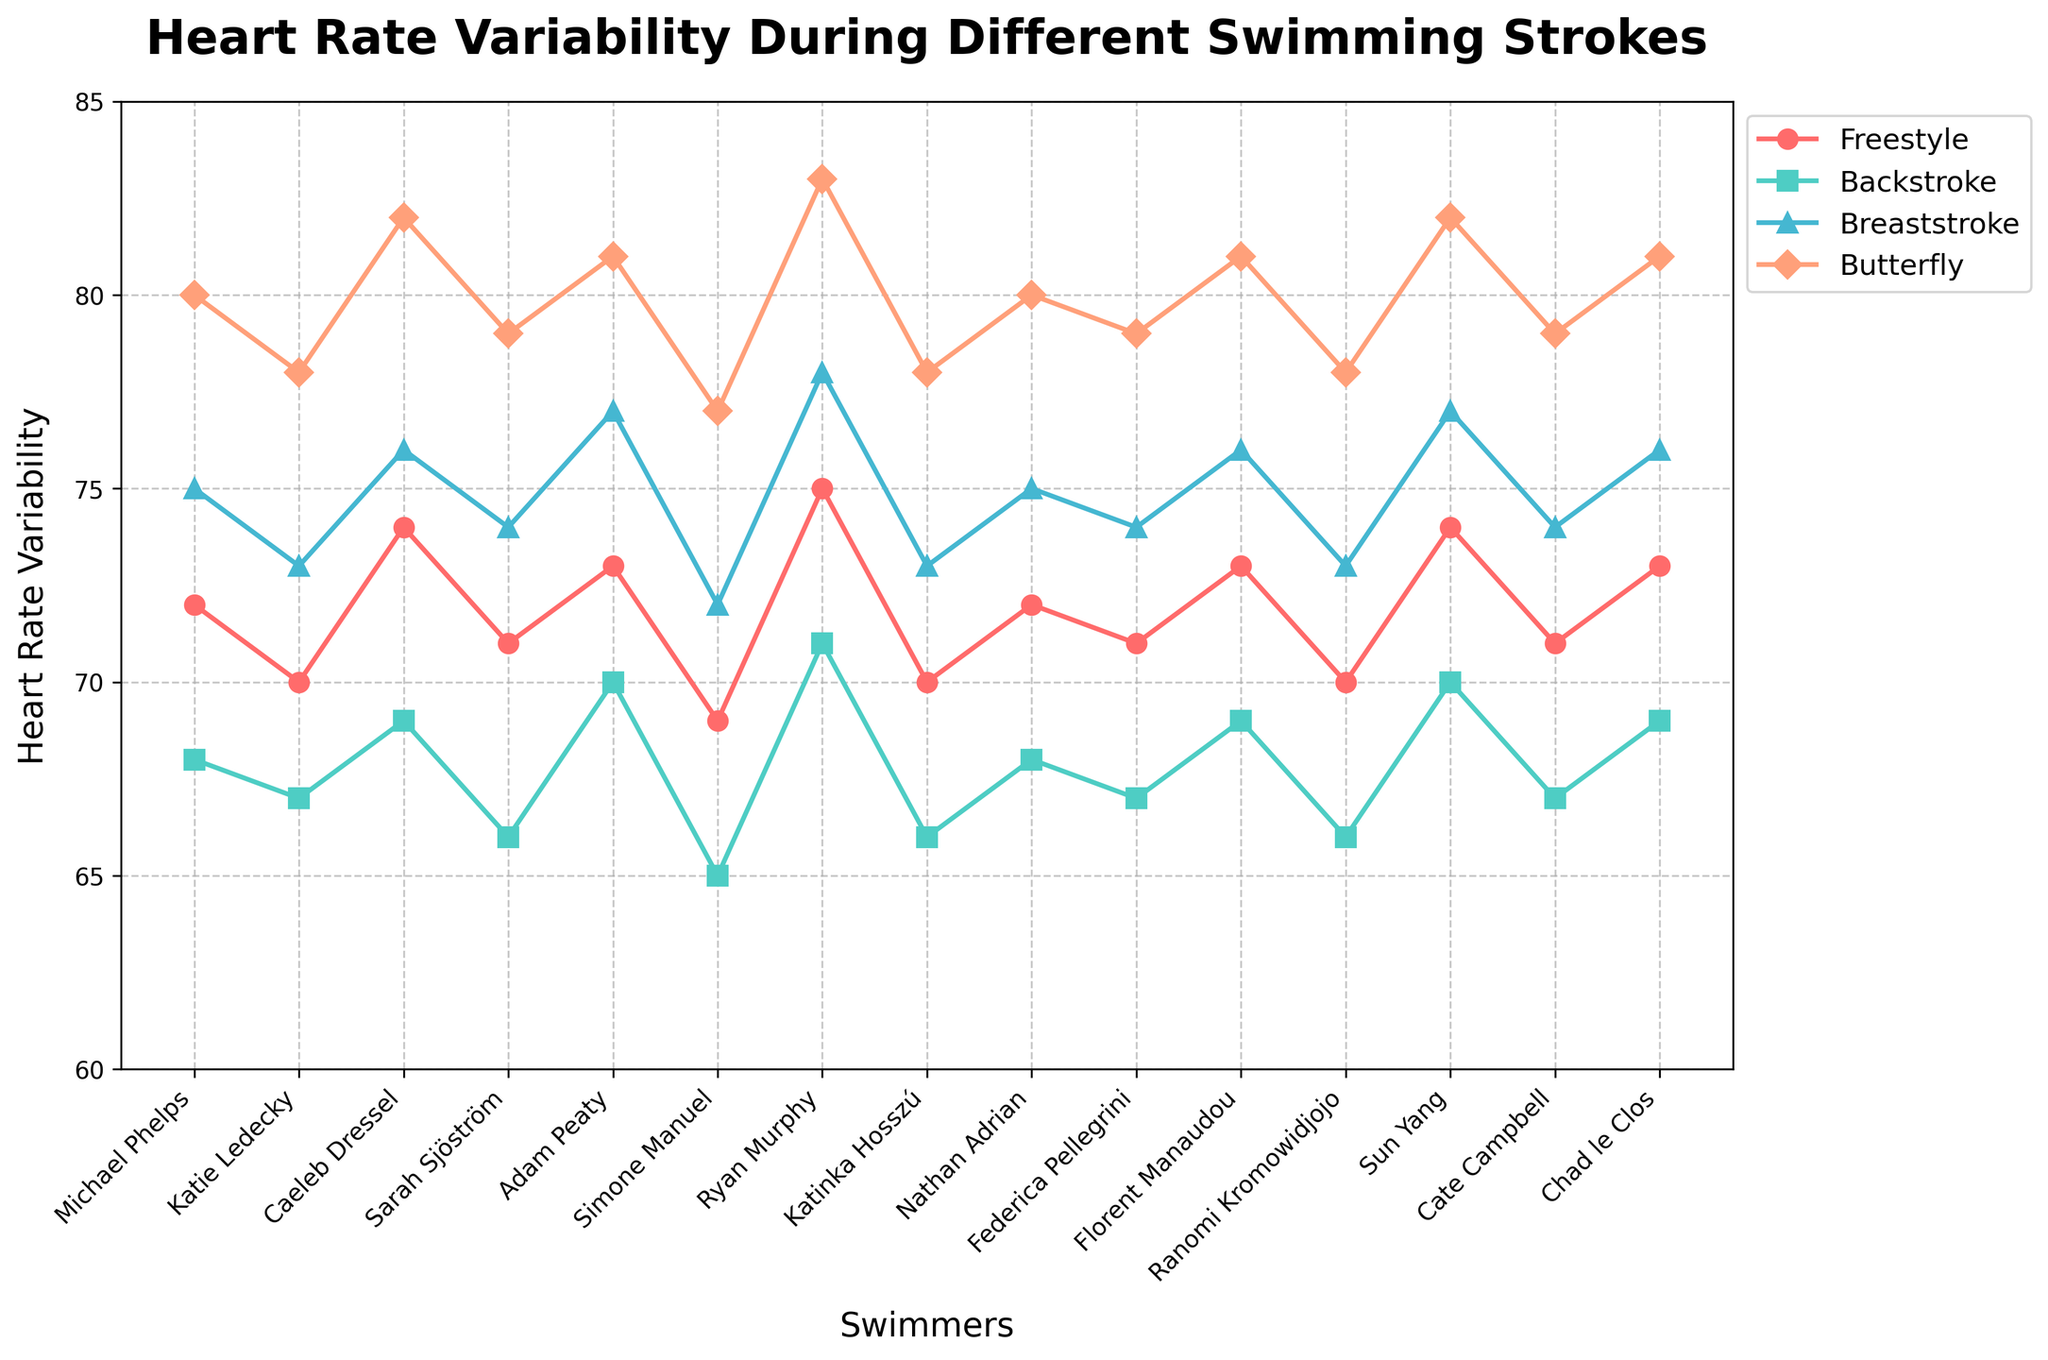What's the highest heart rate variability observed and during which stroke? To find the highest heart rate variability, visually scan the y-axis and find the peak value across all lines representing different strokes. The highest value is observed where the Butterfly stroke line reaches its peak. All four Butterfly lines peak at 83, indicating that Ryan Murphy's heart rate variability is the highest during the Butterfly stroke.
Answer: 83, Butterfly Which swimmer has the lowest heart rate variability for Breaststroke? To determine the lowest heart rate variability for Breaststroke, look for the lowest point on the Breaststroke line (color-coded accordingly). Simone Manuel’s heart rate variability has the lowest value at 72 for Breaststroke.
Answer: Simone Manuel What's the average heart rate variability for Michael Phelps? Calculate the average heart rate variability of Michael Phelps by summing the values for Freestyle (72), Backstroke (68), Breaststroke (75), and Butterfly (80), then dividing by 4. (72 + 68 + 75 + 80) / 4 = 73.75
Answer: 73.75 Which swimmer shows the greatest difference in heart rate variability between Freestyle and Butterfly? Calculate the difference between Freestyle and Butterfly for each swimmer. The swimmer with the most significant difference is Ryan Murphy, who has a difference of 8 (83 - 75 = 8).
Answer: Ryan Murphy How many strokes have a heart rate variability of exactly 70 for any swimmer? Visually scan each of the stroke lines to count the number of instances where they pass through y = 70. There are four instances: Katie Ledecky (Freestyle), Katinka Hosszú (Freestyle), Sun Yang (Freestyle), Adam Peaty (Backstroke).
Answer: 4 Who has a higher heart rate variability in Backstroke, Nathan Adrian or Adam Peaty? Compare the heart rate variabilities of Nathan Adrian and Adam Peaty for Backstroke. Nathan Adrian has 68, while Adam Peaty has 70. Adam Peaty's heart rate variability is higher.
Answer: Adam Peaty What is the median heart rate variability for the Butterfly stroke? To find the median, list all heart rate variability values for Butterfly in ascending order: 77, 78, 78, 78, 78, 79, 79, 79, 80, 80, 80, 81, 81, 81, 82, 82, 82, 83. The median value (middle value in this ordered list) is 80.
Answer: 80 Among Freestyle and Backstroke, which stroke generally shows more variability in heart rate across all swimmers? To determine which stroke has more variability, compare the range (difference between max and min values) for Freestyle (max 75, min 69, range 75-69 = 6) and Backstroke (max 71, min 65, range 71-65 = 6). Both have the same range, but Backstroke shows more clustering at lower values, implying variability is similar but slightly more pronounced on the lower range for Backstroke.
Answer: Backstroke Which athlete has the closest heart rate variability values across all four strokes? Compare the differences in heart rate variability across all strokes for each athlete. Simone Manuel has values of 69, 65, 72, and 77, showing the smallest spread (77 - 65 = 12).
Answer: Simone Manuel 